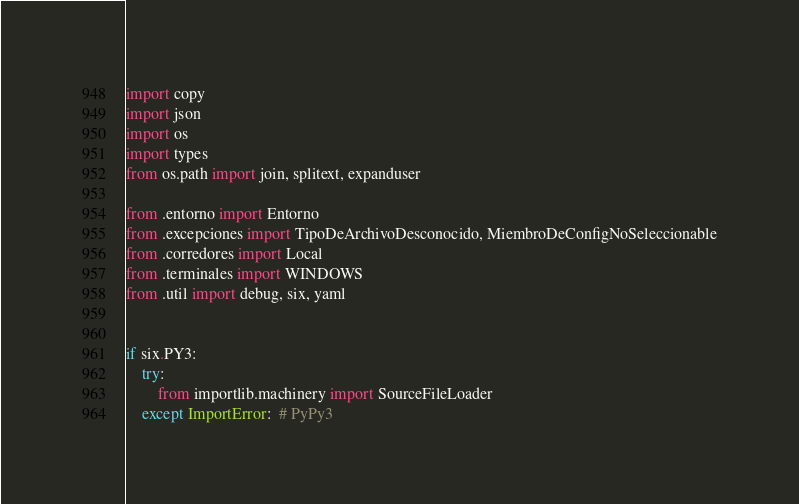<code> <loc_0><loc_0><loc_500><loc_500><_Python_>import copy
import json
import os
import types
from os.path import join, splitext, expanduser

from .entorno import Entorno
from .excepciones import TipoDeArchivoDesconocido, MiembroDeConfigNoSeleccionable
from .corredores import Local
from .terminales import WINDOWS
from .util import debug, six, yaml


if six.PY3:
    try:
        from importlib.machinery import SourceFileLoader
    except ImportError:  # PyPy3</code> 